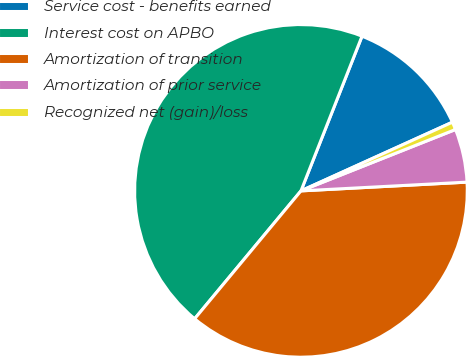Convert chart to OTSL. <chart><loc_0><loc_0><loc_500><loc_500><pie_chart><fcel>Service cost - benefits earned<fcel>Interest cost on APBO<fcel>Amortization of transition<fcel>Amortization of prior service<fcel>Recognized net (gain)/loss<nl><fcel>12.24%<fcel>44.95%<fcel>36.88%<fcel>5.18%<fcel>0.76%<nl></chart> 